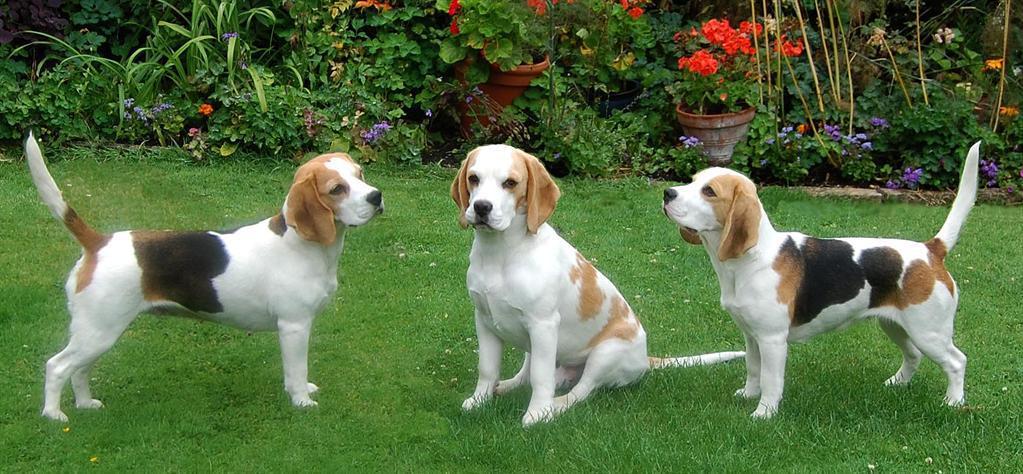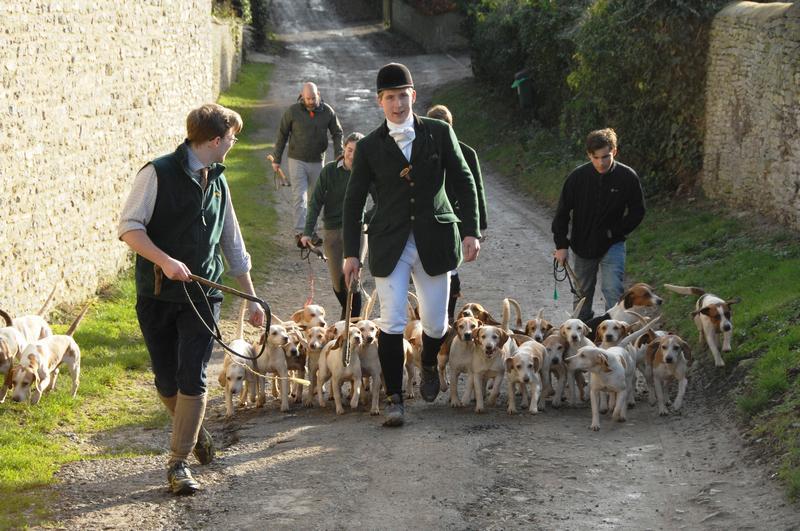The first image is the image on the left, the second image is the image on the right. For the images shown, is this caption "An image shows a group of at least five people walking with a pack of dogs." true? Answer yes or no. Yes. The first image is the image on the left, the second image is the image on the right. Evaluate the accuracy of this statement regarding the images: "In one image, men wearing hunting clothes are with a pack of dogs adjacent to a stone wall.". Is it true? Answer yes or no. Yes. 